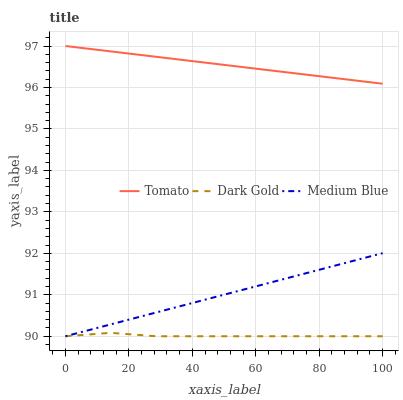Does Dark Gold have the minimum area under the curve?
Answer yes or no. Yes. Does Tomato have the maximum area under the curve?
Answer yes or no. Yes. Does Medium Blue have the minimum area under the curve?
Answer yes or no. No. Does Medium Blue have the maximum area under the curve?
Answer yes or no. No. Is Tomato the smoothest?
Answer yes or no. Yes. Is Dark Gold the roughest?
Answer yes or no. Yes. Is Medium Blue the smoothest?
Answer yes or no. No. Is Medium Blue the roughest?
Answer yes or no. No. Does Medium Blue have the lowest value?
Answer yes or no. Yes. Does Tomato have the highest value?
Answer yes or no. Yes. Does Medium Blue have the highest value?
Answer yes or no. No. Is Medium Blue less than Tomato?
Answer yes or no. Yes. Is Tomato greater than Medium Blue?
Answer yes or no. Yes. Does Dark Gold intersect Medium Blue?
Answer yes or no. Yes. Is Dark Gold less than Medium Blue?
Answer yes or no. No. Is Dark Gold greater than Medium Blue?
Answer yes or no. No. Does Medium Blue intersect Tomato?
Answer yes or no. No. 